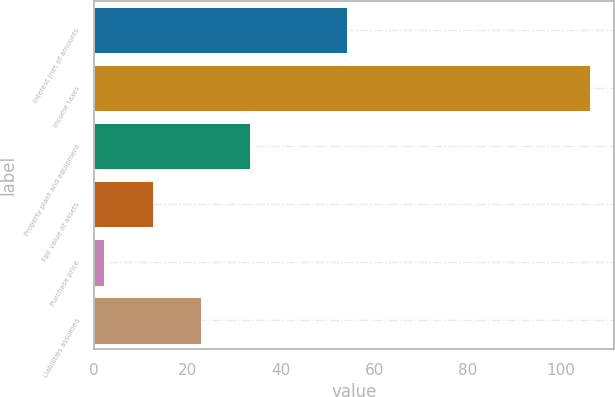<chart> <loc_0><loc_0><loc_500><loc_500><bar_chart><fcel>Interest (net of amounts<fcel>Income taxes<fcel>Property plant and equipment<fcel>Fair value of assets<fcel>Purchase price<fcel>Liabilities assumed<nl><fcel>54.11<fcel>106.1<fcel>33.33<fcel>12.55<fcel>2.16<fcel>22.94<nl></chart> 